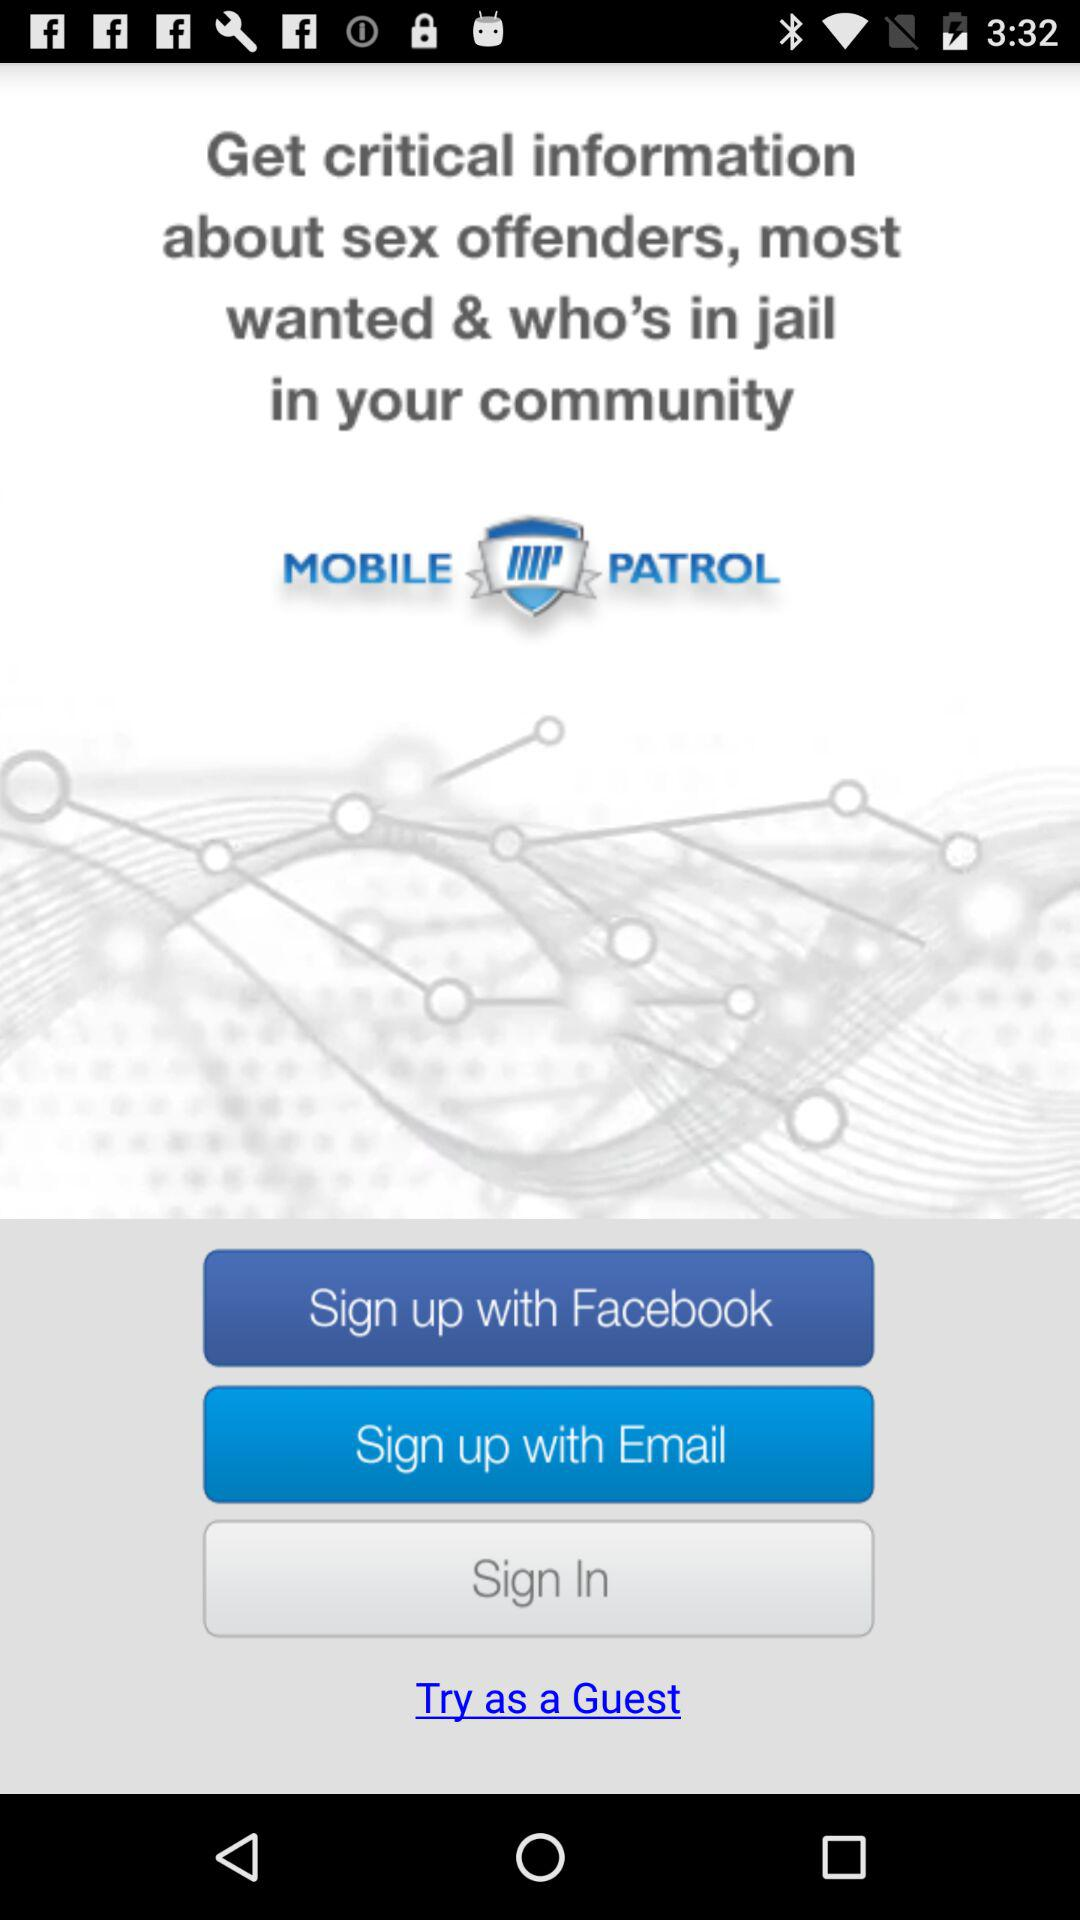What is the name of the application? The name of the application is "MobilePatrol". 